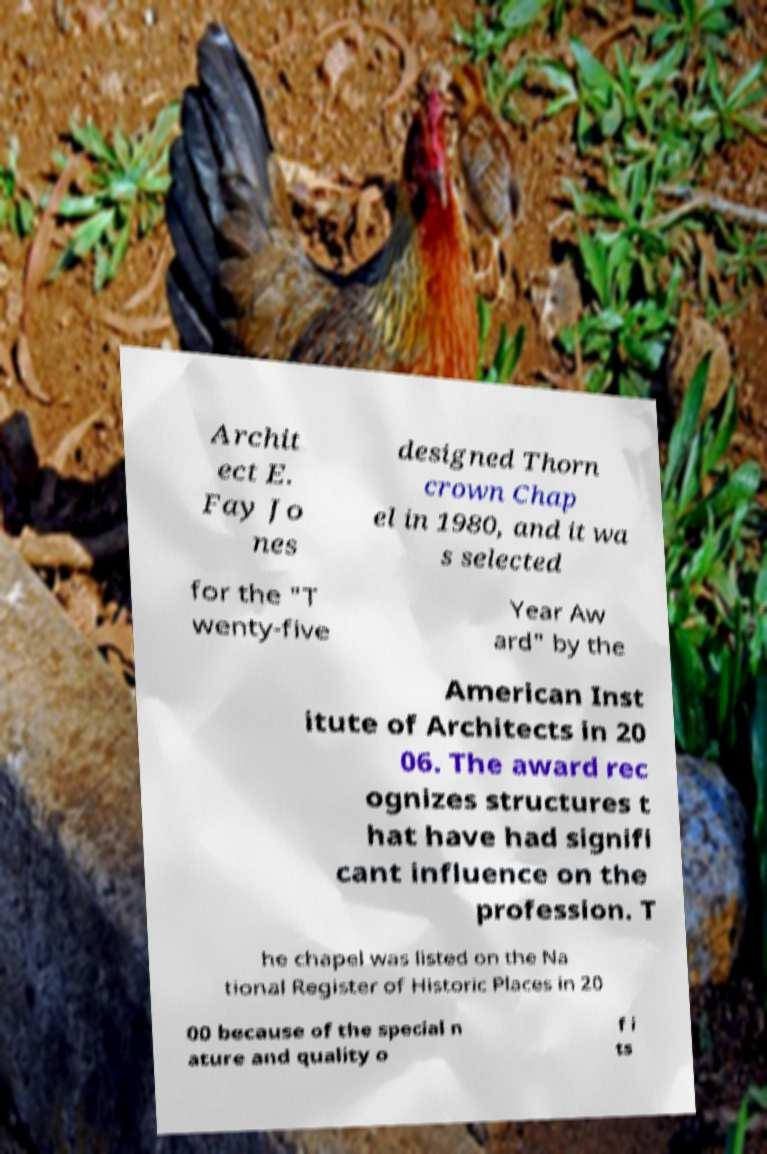What messages or text are displayed in this image? I need them in a readable, typed format. Archit ect E. Fay Jo nes designed Thorn crown Chap el in 1980, and it wa s selected for the "T wenty-five Year Aw ard" by the American Inst itute of Architects in 20 06. The award rec ognizes structures t hat have had signifi cant influence on the profession. T he chapel was listed on the Na tional Register of Historic Places in 20 00 because of the special n ature and quality o f i ts 